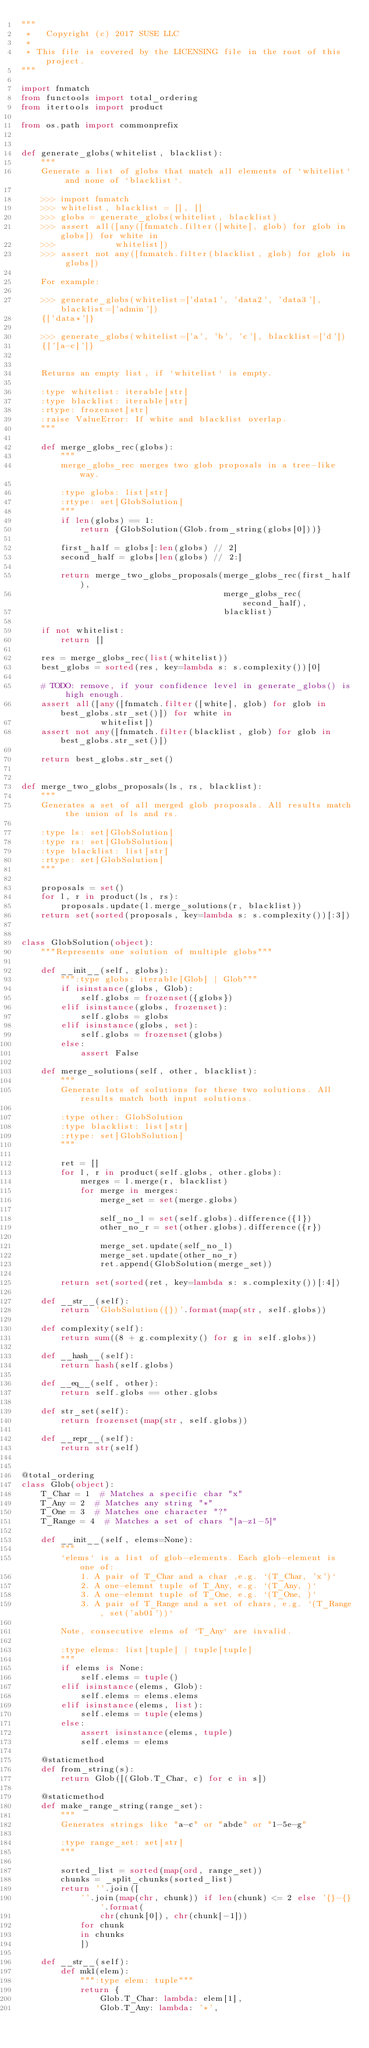<code> <loc_0><loc_0><loc_500><loc_500><_Python_>"""
 *   Copyright (c) 2017 SUSE LLC
 *
 * This file is covered by the LICENSING file in the root of this project.
"""

import fnmatch
from functools import total_ordering
from itertools import product

from os.path import commonprefix


def generate_globs(whitelist, blacklist):
    """
    Generate a list of globs that match all elements of `whitelist` and none of `blacklist`.

    >>> import fnmatch
    >>> whitelist, blacklist = [], []
    >>> globs = generate_globs(whitelist, blacklist)
    >>> assert all([any([fnmatch.filter([white], glob) for glob in globs]) for white in
    >>>            whitelist])
    >>> assert not any([fnmatch.filter(blacklist, glob) for glob in globs])

    For example:

    >>> generate_globs(whitelist=['data1', 'data2', 'data3'], blacklist=['admin'])
    {['data*']}

    >>> generate_globs(whitelist=['a', 'b', 'c'], blacklist=['d'])
    {['[a-c]']}


    Returns an empty list, if `whitelist` is empty.

    :type whitelist: iterable[str]
    :type blacklist: iterable[str]
    :rtype: frozenset[str]
    :raise ValueError: If white and blacklist overlap.
    """

    def merge_globs_rec(globs):
        """
        merge_globs_rec merges two glob proposals in a tree-like way.

        :type globs: list[str]
        :rtype: set[GlobSolution]
        """
        if len(globs) == 1:
            return {GlobSolution(Glob.from_string(globs[0]))}

        first_half = globs[:len(globs) // 2]
        second_half = globs[len(globs) // 2:]

        return merge_two_globs_proposals(merge_globs_rec(first_half),
                                         merge_globs_rec(second_half),
                                         blacklist)

    if not whitelist:
        return []

    res = merge_globs_rec(list(whitelist))
    best_globs = sorted(res, key=lambda s: s.complexity())[0]

    # TODO: remove, if your confidence level in generate_globs() is high enough.
    assert all([any([fnmatch.filter([white], glob) for glob in best_globs.str_set()]) for white in
                whitelist])
    assert not any([fnmatch.filter(blacklist, glob) for glob in best_globs.str_set()])

    return best_globs.str_set()


def merge_two_globs_proposals(ls, rs, blacklist):
    """
    Generates a set of all merged glob proposals. All results match the union of ls and rs.

    :type ls: set[GlobSolution]
    :type rs: set[GlobSolution]
    :type blacklist: list[str]
    :rtype: set[GlobSolution]
    """

    proposals = set()
    for l, r in product(ls, rs):
        proposals.update(l.merge_solutions(r, blacklist))
    return set(sorted(proposals, key=lambda s: s.complexity())[:3])


class GlobSolution(object):
    """Represents one solution of multiple globs"""

    def __init__(self, globs):
        """:type globs: iterable[Glob] | Glob"""
        if isinstance(globs, Glob):
            self.globs = frozenset({globs})
        elif isinstance(globs, frozenset):
            self.globs = globs
        elif isinstance(globs, set):
            self.globs = frozenset(globs)
        else:
            assert False

    def merge_solutions(self, other, blacklist):
        """
        Generate lots of solutions for these two solutions. All results match both input solutions.

        :type other: GlobSolution
        :type blacklist: list[str]
        :rtype: set[GlobSolution]
        """

        ret = []
        for l, r in product(self.globs, other.globs):
            merges = l.merge(r, blacklist)
            for merge in merges:
                merge_set = set(merge.globs)

                self_no_l = set(self.globs).difference({l})
                other_no_r = set(other.globs).difference({r})

                merge_set.update(self_no_l)
                merge_set.update(other_no_r)
                ret.append(GlobSolution(merge_set))

        return set(sorted(ret, key=lambda s: s.complexity())[:4])

    def __str__(self):
        return 'GlobSolution({})'.format(map(str, self.globs))

    def complexity(self):
        return sum((8 + g.complexity() for g in self.globs))

    def __hash__(self):
        return hash(self.globs)

    def __eq__(self, other):
        return self.globs == other.globs

    def str_set(self):
        return frozenset(map(str, self.globs))

    def __repr__(self):
        return str(self)


@total_ordering
class Glob(object):
    T_Char = 1  # Matches a specific char "x"
    T_Any = 2  # Matches any string "*"
    T_One = 3  # Matches one character "?"
    T_Range = 4  # Matches a set of chars "[a-z1-5]"

    def __init__(self, elems=None):
        """
        `elems` is a list of glob-elements. Each glob-element is one of:
            1. A pair of T_Char and a char ,e.g. `(T_Char, 'x')`
            2. A one-elemnt tuple of T_Any, e.g. `(T_Any, )`
            3. A one-elemnt tuple of T_One, e.g. `(T_One, )`
            3. A pair of T_Range and a set of chars, e.g. `(T_Range, set('ab01'))`

        Note, consecutive elems of `T_Any` are invalid.

        :type elems: list[tuple] | tuple[tuple]
        """
        if elems is None:
            self.elems = tuple()
        elif isinstance(elems, Glob):
            self.elems = elems.elems
        elif isinstance(elems, list):
            self.elems = tuple(elems)
        else:
            assert isinstance(elems, tuple)
            self.elems = elems

    @staticmethod
    def from_string(s):
        return Glob([(Glob.T_Char, c) for c in s])

    @staticmethod
    def make_range_string(range_set):
        """
        Generates strings like "a-c" or "abde" or "1-5e-g"

        :type range_set: set[str]
        """

        sorted_list = sorted(map(ord, range_set))
        chunks = _split_chunks(sorted_list)
        return ''.join([
            ''.join(map(chr, chunk)) if len(chunk) <= 2 else '{}-{}'.format(
                chr(chunk[0]), chr(chunk[-1]))
            for chunk
            in chunks
            ])

    def __str__(self):
        def mk1(elem):
            """:type elem: tuple"""
            return {
                Glob.T_Char: lambda: elem[1],
                Glob.T_Any: lambda: '*',</code> 